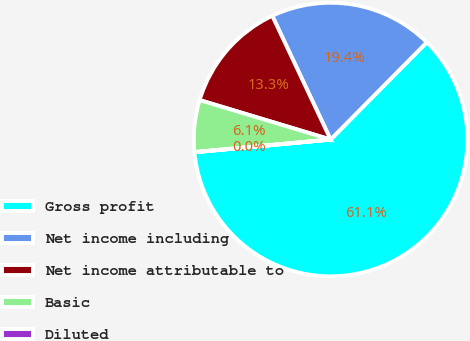<chart> <loc_0><loc_0><loc_500><loc_500><pie_chart><fcel>Gross profit<fcel>Net income including<fcel>Net income attributable to<fcel>Basic<fcel>Diluted<nl><fcel>61.1%<fcel>19.43%<fcel>13.33%<fcel>6.12%<fcel>0.02%<nl></chart> 